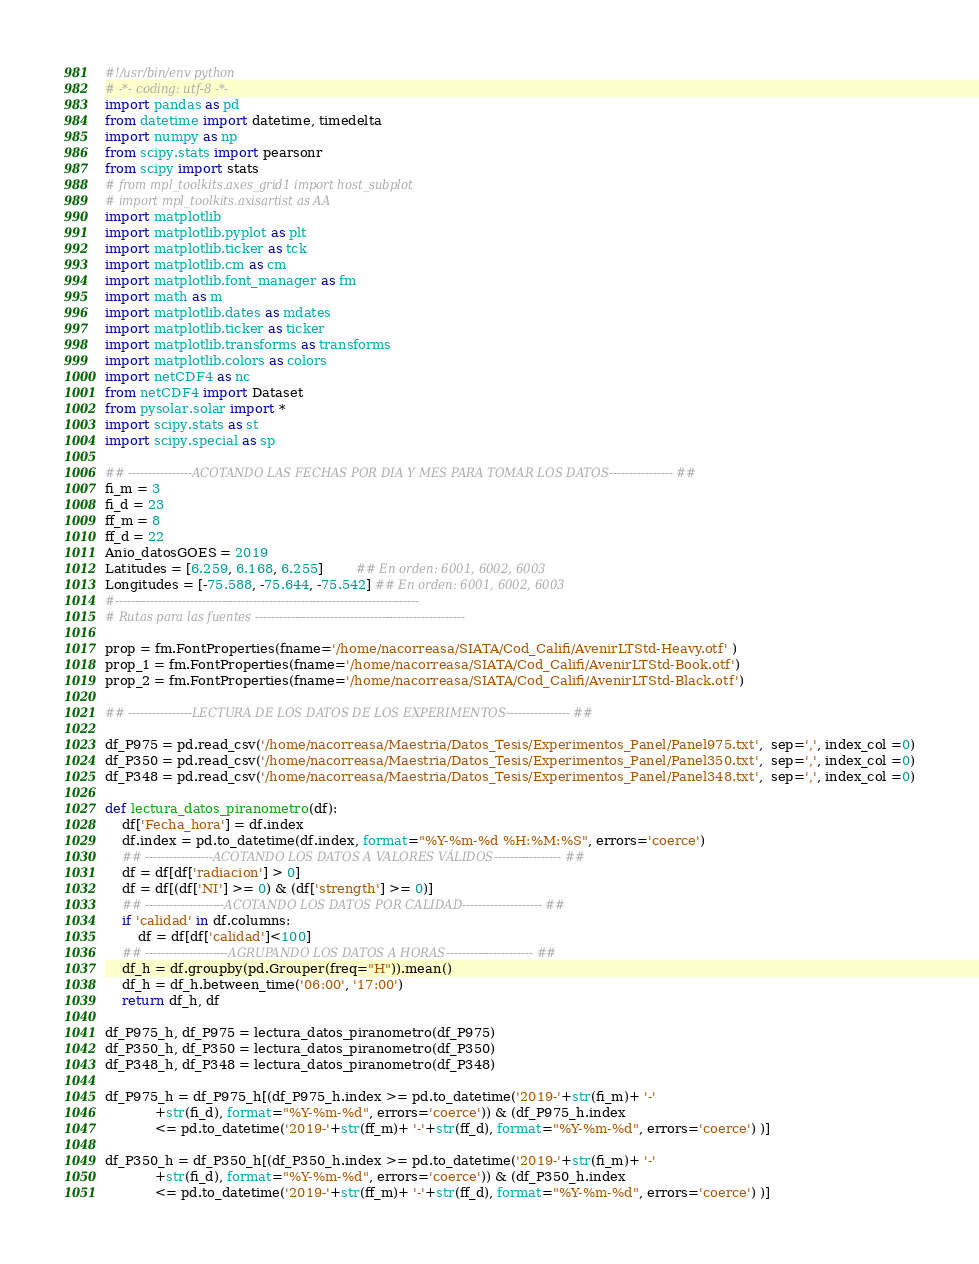<code> <loc_0><loc_0><loc_500><loc_500><_Python_>#!/usr/bin/env python
# -*- coding: utf-8 -*-
import pandas as pd
from datetime import datetime, timedelta
import numpy as np
from scipy.stats import pearsonr
from scipy import stats
# from mpl_toolkits.axes_grid1 import host_subplot
# import mpl_toolkits.axisartist as AA
import matplotlib
import matplotlib.pyplot as plt
import matplotlib.ticker as tck
import matplotlib.cm as cm
import matplotlib.font_manager as fm
import math as m
import matplotlib.dates as mdates
import matplotlib.ticker as ticker
import matplotlib.transforms as transforms
import matplotlib.colors as colors
import netCDF4 as nc
from netCDF4 import Dataset
from pysolar.solar import *
import scipy.stats as st
import scipy.special as sp

## ----------------ACOTANDO LAS FECHAS POR DIA Y MES PARA TOMAR LOS DATOS---------------- ##
fi_m = 3
fi_d = 23
ff_m = 8
ff_d = 22
Anio_datosGOES = 2019
Latitudes = [6.259, 6.168, 6.255]        ## En orden: 6001, 6002, 6003
Longitudes = [-75.588, -75.644, -75.542] ## En orden: 6001, 6002, 6003
#-----------------------------------------------------------------------------
# Rutas para las fuentes -----------------------------------------------------

prop = fm.FontProperties(fname='/home/nacorreasa/SIATA/Cod_Califi/AvenirLTStd-Heavy.otf' )
prop_1 = fm.FontProperties(fname='/home/nacorreasa/SIATA/Cod_Califi/AvenirLTStd-Book.otf')
prop_2 = fm.FontProperties(fname='/home/nacorreasa/SIATA/Cod_Califi/AvenirLTStd-Black.otf')

## ----------------LECTURA DE LOS DATOS DE LOS EXPERIMENTOS---------------- ##

df_P975 = pd.read_csv('/home/nacorreasa/Maestria/Datos_Tesis/Experimentos_Panel/Panel975.txt',  sep=',', index_col =0)
df_P350 = pd.read_csv('/home/nacorreasa/Maestria/Datos_Tesis/Experimentos_Panel/Panel350.txt',  sep=',', index_col =0)
df_P348 = pd.read_csv('/home/nacorreasa/Maestria/Datos_Tesis/Experimentos_Panel/Panel348.txt',  sep=',', index_col =0)

def lectura_datos_piranometro(df):
    df['Fecha_hora'] = df.index
    df.index = pd.to_datetime(df.index, format="%Y-%m-%d %H:%M:%S", errors='coerce')
    ## -----------------ACOTANDO LOS DATOS A VALORES VÁLIDOS----------------- ##
    df = df[df['radiacion'] > 0]
    df = df[(df['NI'] >= 0) & (df['strength'] >= 0)]
    ## --------------------ACOTANDO LOS DATOS POR CALIDAD-------------------- ##
    if 'calidad' in df.columns:
        df = df[df['calidad']<100]
    ## ---------------------AGRUPANDO LOS DATOS A HORAS---------------------- ##
    df_h = df.groupby(pd.Grouper(freq="H")).mean()
    df_h = df_h.between_time('06:00', '17:00')
    return df_h, df

df_P975_h, df_P975 = lectura_datos_piranometro(df_P975)
df_P350_h, df_P350 = lectura_datos_piranometro(df_P350)
df_P348_h, df_P348 = lectura_datos_piranometro(df_P348)

df_P975_h = df_P975_h[(df_P975_h.index >= pd.to_datetime('2019-'+str(fi_m)+ '-'
            +str(fi_d), format="%Y-%m-%d", errors='coerce')) & (df_P975_h.index
            <= pd.to_datetime('2019-'+str(ff_m)+ '-'+str(ff_d), format="%Y-%m-%d", errors='coerce') )]

df_P350_h = df_P350_h[(df_P350_h.index >= pd.to_datetime('2019-'+str(fi_m)+ '-'
            +str(fi_d), format="%Y-%m-%d", errors='coerce')) & (df_P350_h.index
            <= pd.to_datetime('2019-'+str(ff_m)+ '-'+str(ff_d), format="%Y-%m-%d", errors='coerce') )]
</code> 